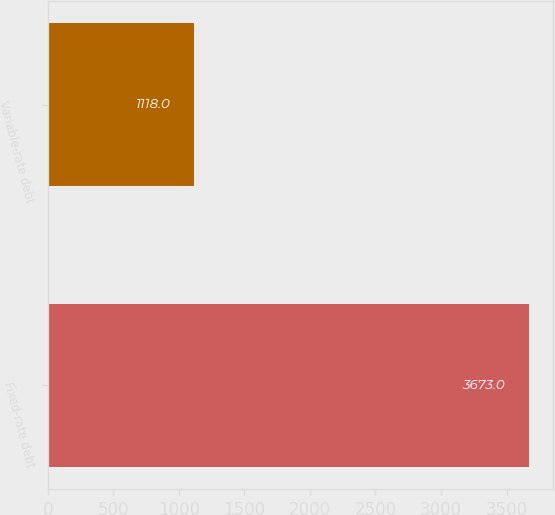Convert chart. <chart><loc_0><loc_0><loc_500><loc_500><bar_chart><fcel>Fixed-rate debt<fcel>Variable-rate debt<nl><fcel>3673<fcel>1118<nl></chart> 